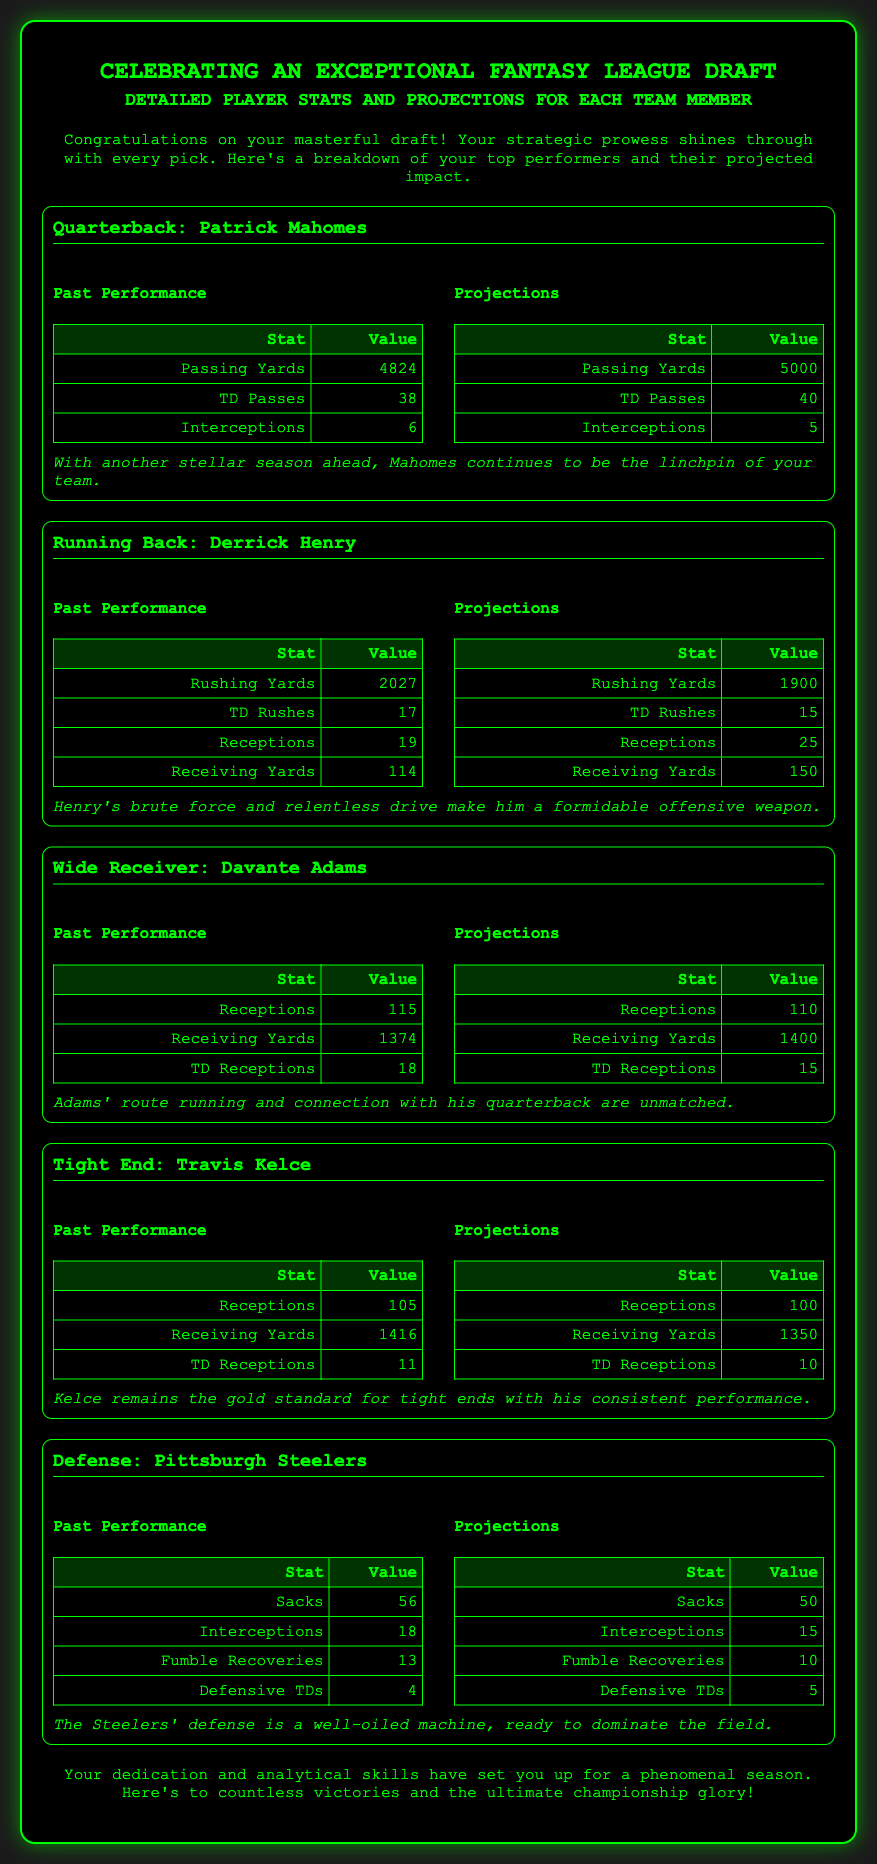What is the title of the document? The title of the document is found at the top and is "Fantasy League Draft Celebration."
Answer: Fantasy League Draft Celebration Who is the quarterback mentioned? The card lists Patrick Mahomes as the quarterback in the player's section.
Answer: Patrick Mahomes What is Derrick Henry's rushing yards from past performance? The document specifies Derrick Henry's past performance rushing yards as 2027.
Answer: 2027 How many touchdowns did Davante Adams have in past performance? The past performance section for Davante Adams details his touchdowns as 18.
Answer: 18 What are the projected passing yards for Patrick Mahomes? Under the projections for Mahomes, it is specified that he is projected for 5000 passing yards.
Answer: 5000 Which team is highlighted for defense? The document lists the Pittsburgh Steelers as the featured defense.
Answer: Pittsburgh Steelers How many receptions is Travis Kelce projected to have? The document states that Travis Kelce is projected to have 100 receptions.
Answer: 100 What is the note regarding Derrick Henry's performance? The note elaborates on Henry's performance, describing him as a formidable offensive weapon.
Answer: formidable offensive weapon How many total interceptions did the Pittsburgh Steelers have in past performance? The past performance section for the Steelers shows a total of 18 interceptions.
Answer: 18 